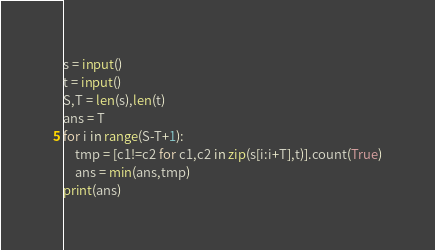Convert code to text. <code><loc_0><loc_0><loc_500><loc_500><_Python_>s = input()
t = input()
S,T = len(s),len(t)
ans = T
for i in range(S-T+1):
    tmp = [c1!=c2 for c1,c2 in zip(s[i:i+T],t)].count(True)
    ans = min(ans,tmp)
print(ans)
</code> 